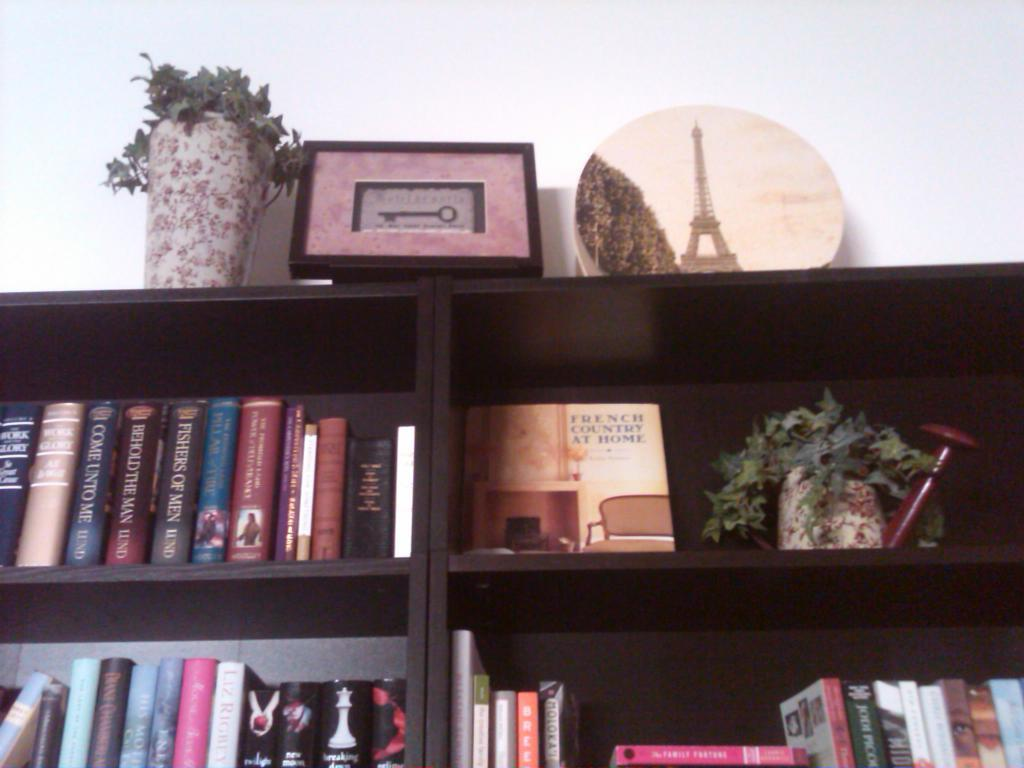<image>
Describe the image concisely. Book shelf that shows a book titled Come Unto Me. 